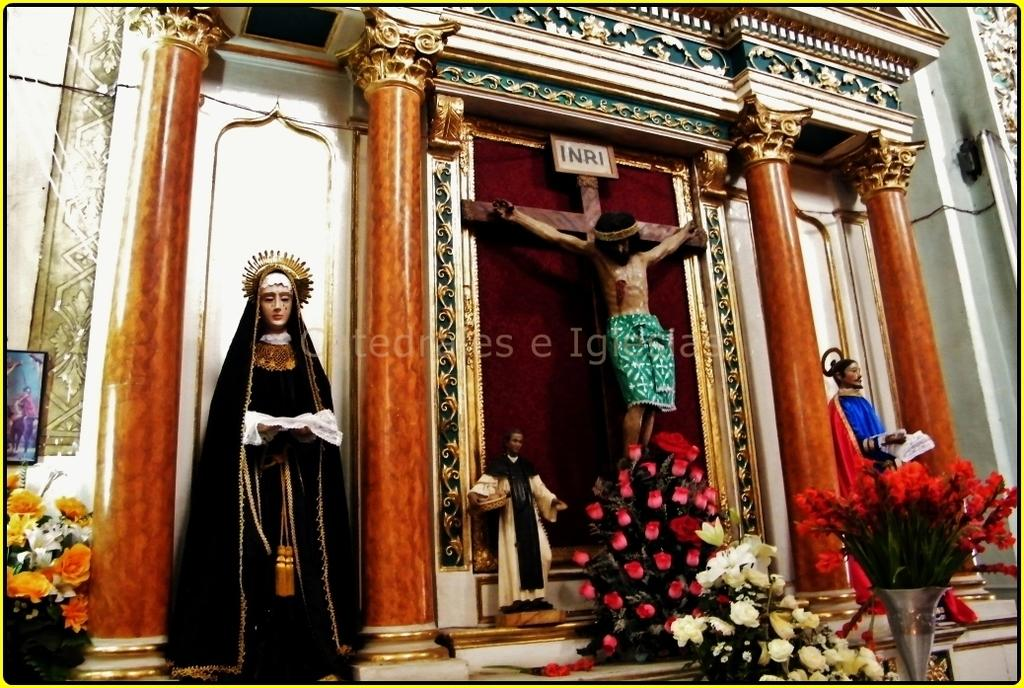<image>
Create a compact narrative representing the image presented. A Crucifixion of Jesus on the cross under a sign that says INRI. 